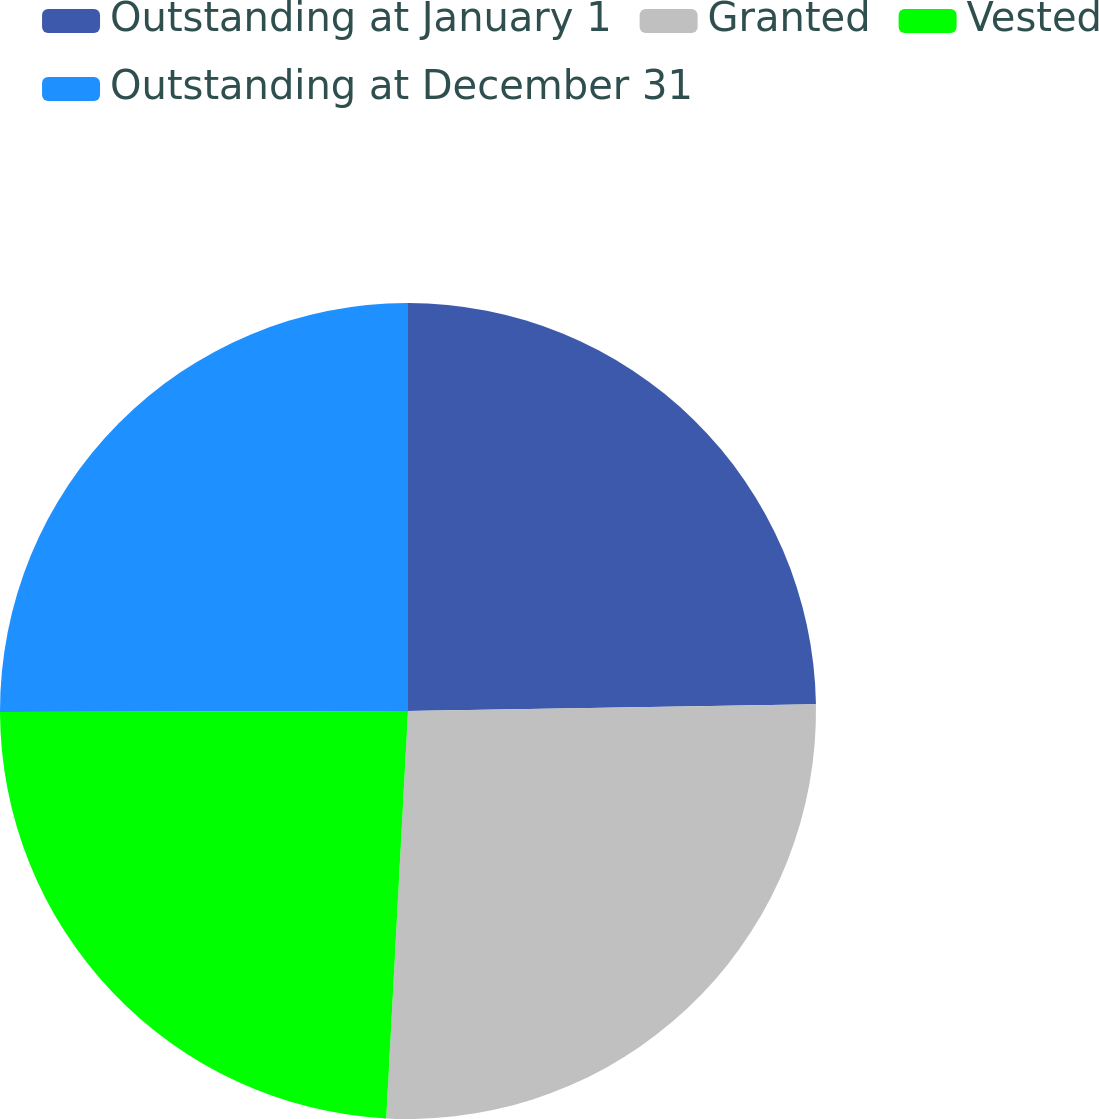Convert chart. <chart><loc_0><loc_0><loc_500><loc_500><pie_chart><fcel>Outstanding at January 1<fcel>Granted<fcel>Vested<fcel>Outstanding at December 31<nl><fcel>24.74%<fcel>26.11%<fcel>24.11%<fcel>25.04%<nl></chart> 